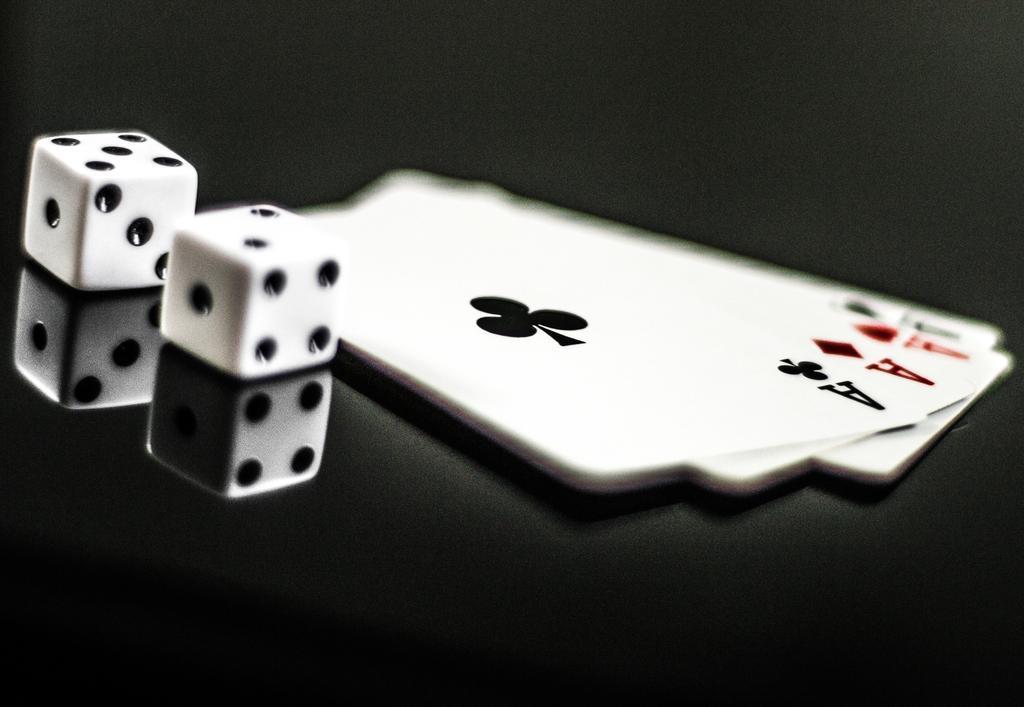Can you describe this image briefly? These are the cubes, on the right side there are playing cards. 